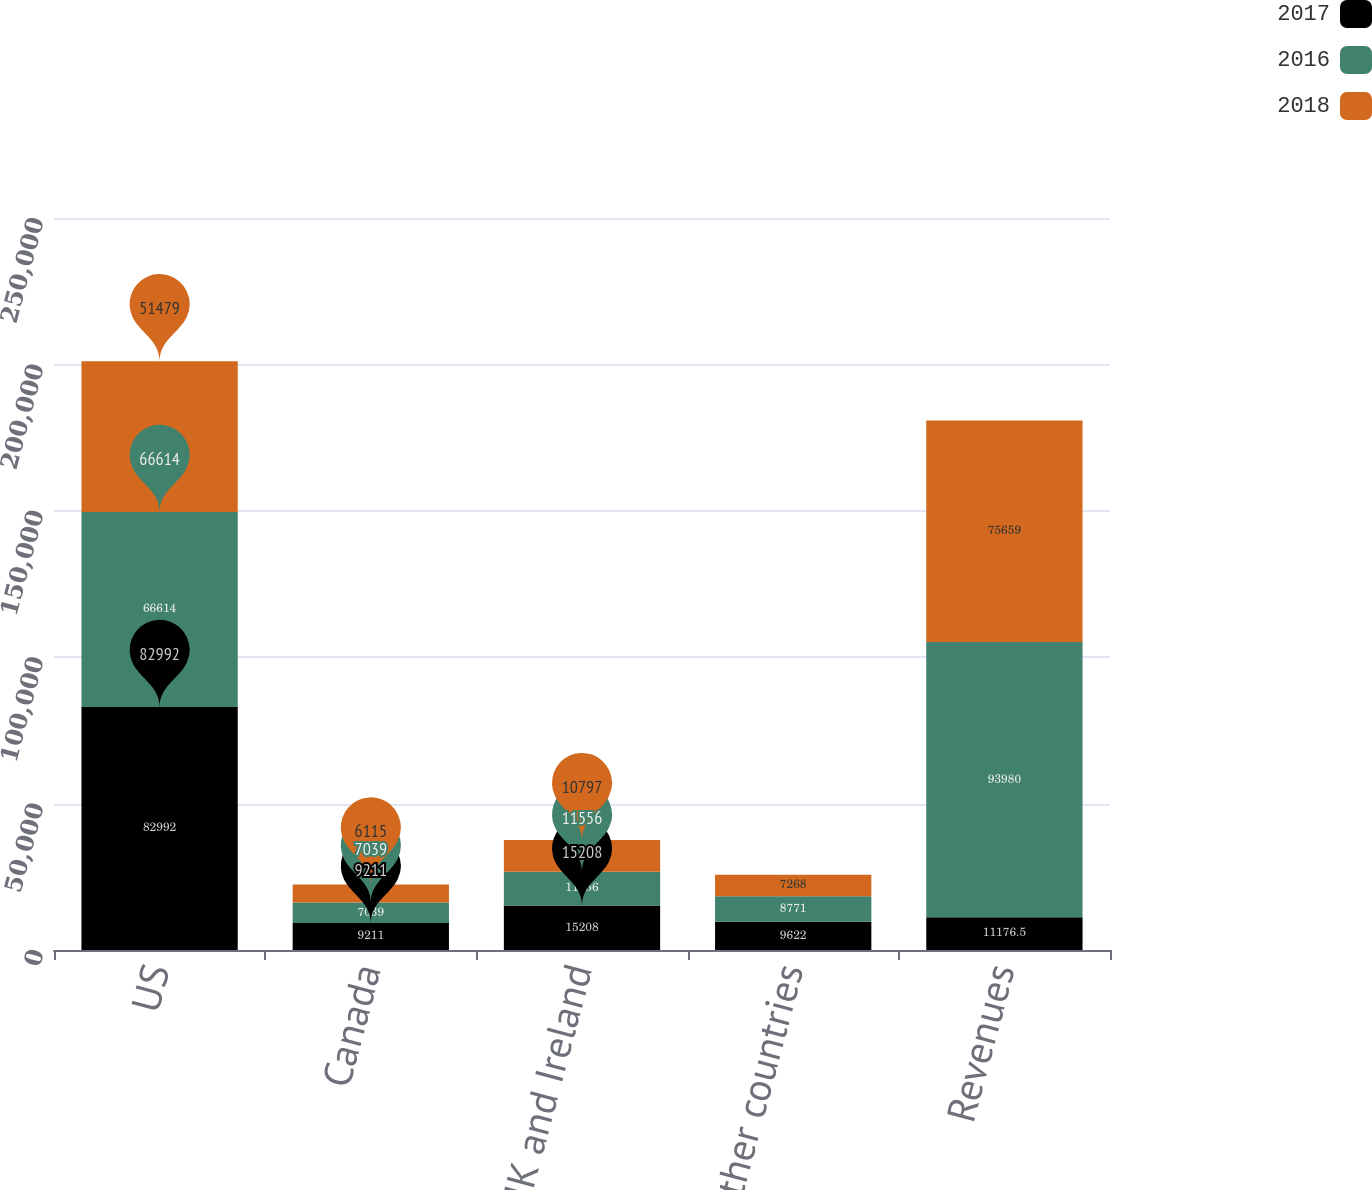<chart> <loc_0><loc_0><loc_500><loc_500><stacked_bar_chart><ecel><fcel>US<fcel>Canada<fcel>UK and Ireland<fcel>Other countries<fcel>Revenues<nl><fcel>2017<fcel>82992<fcel>9211<fcel>15208<fcel>9622<fcel>11176.5<nl><fcel>2016<fcel>66614<fcel>7039<fcel>11556<fcel>8771<fcel>93980<nl><fcel>2018<fcel>51479<fcel>6115<fcel>10797<fcel>7268<fcel>75659<nl></chart> 